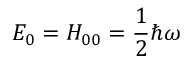<formula> <loc_0><loc_0><loc_500><loc_500>E _ { 0 } = H _ { 0 0 } = \frac { 1 } { 2 } \hbar { \omega }</formula> 